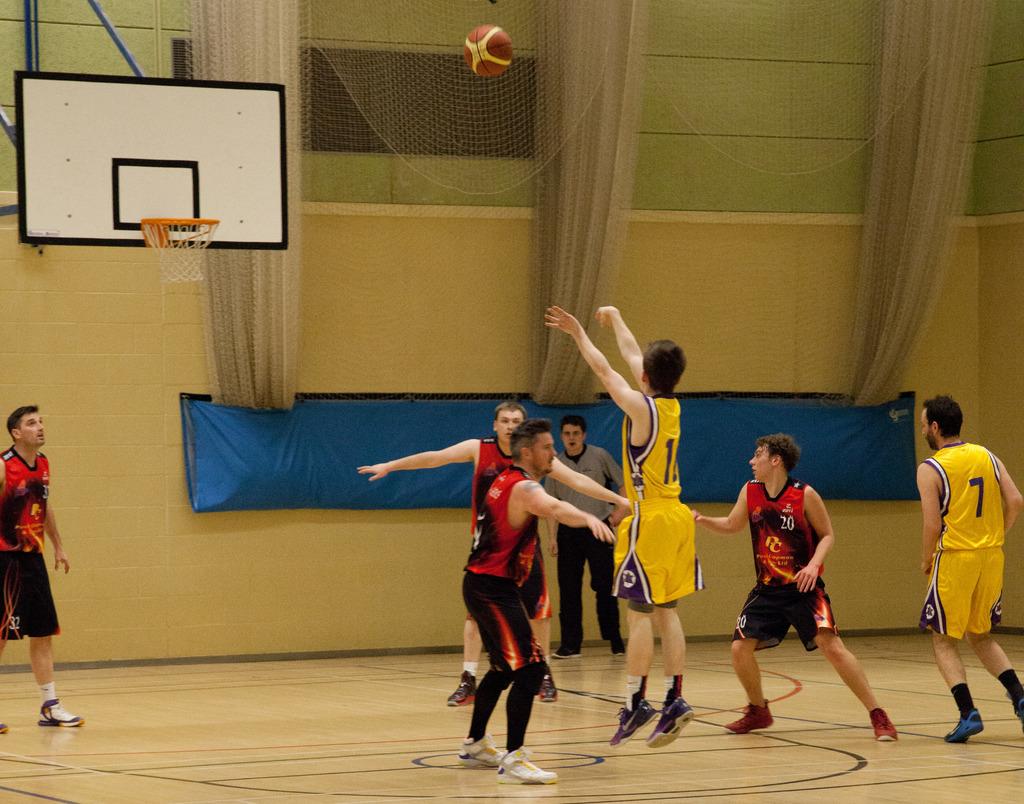What number is the player on the far right?
Provide a succinct answer. 7. What is the number of the player in red that is between the two players in yellow?
Your answer should be very brief. 20. 